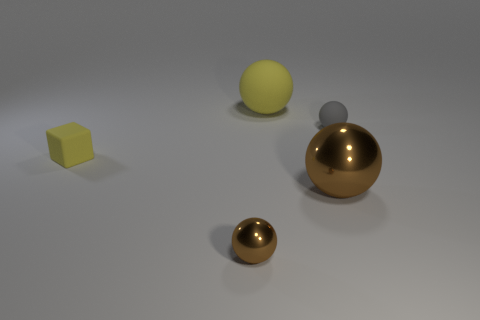There is a shiny object that is behind the tiny brown ball; does it have the same shape as the small rubber object to the left of the big rubber sphere? No, the shiny object behind the tiny brown ball does not share the same shape as the small rubber object. The shiny object appears to be a reflective sphere, while the small rubber object to the left of the larger rubber sphere is cube-shaped. 